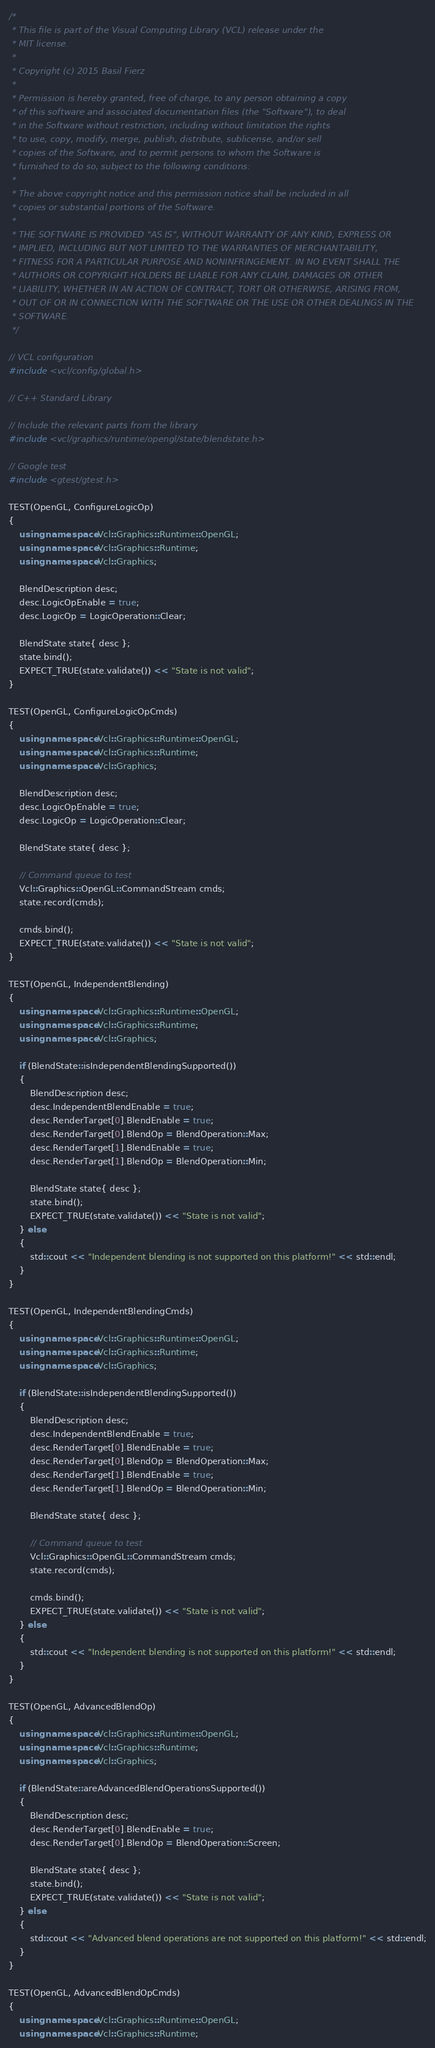Convert code to text. <code><loc_0><loc_0><loc_500><loc_500><_C++_>/*
 * This file is part of the Visual Computing Library (VCL) release under the
 * MIT license.
 *
 * Copyright (c) 2015 Basil Fierz
 *
 * Permission is hereby granted, free of charge, to any person obtaining a copy
 * of this software and associated documentation files (the "Software"), to deal
 * in the Software without restriction, including without limitation the rights
 * to use, copy, modify, merge, publish, distribute, sublicense, and/or sell
 * copies of the Software, and to permit persons to whom the Software is
 * furnished to do so, subject to the following conditions:
 *
 * The above copyright notice and this permission notice shall be included in all
 * copies or substantial portions of the Software.
 *
 * THE SOFTWARE IS PROVIDED "AS IS", WITHOUT WARRANTY OF ANY KIND, EXPRESS OR
 * IMPLIED, INCLUDING BUT NOT LIMITED TO THE WARRANTIES OF MERCHANTABILITY,
 * FITNESS FOR A PARTICULAR PURPOSE AND NONINFRINGEMENT. IN NO EVENT SHALL THE
 * AUTHORS OR COPYRIGHT HOLDERS BE LIABLE FOR ANY CLAIM, DAMAGES OR OTHER
 * LIABILITY, WHETHER IN AN ACTION OF CONTRACT, TORT OR OTHERWISE, ARISING FROM,
 * OUT OF OR IN CONNECTION WITH THE SOFTWARE OR THE USE OR OTHER DEALINGS IN THE
 * SOFTWARE.
 */

// VCL configuration
#include <vcl/config/global.h>

// C++ Standard Library

// Include the relevant parts from the library
#include <vcl/graphics/runtime/opengl/state/blendstate.h>

// Google test
#include <gtest/gtest.h>

TEST(OpenGL, ConfigureLogicOp)
{
	using namespace Vcl::Graphics::Runtime::OpenGL;
	using namespace Vcl::Graphics::Runtime;
	using namespace Vcl::Graphics;

	BlendDescription desc;
	desc.LogicOpEnable = true;
	desc.LogicOp = LogicOperation::Clear;

	BlendState state{ desc };
	state.bind();
	EXPECT_TRUE(state.validate()) << "State is not valid";
}

TEST(OpenGL, ConfigureLogicOpCmds)
{
	using namespace Vcl::Graphics::Runtime::OpenGL;
	using namespace Vcl::Graphics::Runtime;
	using namespace Vcl::Graphics;

	BlendDescription desc;
	desc.LogicOpEnable = true;
	desc.LogicOp = LogicOperation::Clear;

	BlendState state{ desc };

	// Command queue to test
	Vcl::Graphics::OpenGL::CommandStream cmds;
	state.record(cmds);

	cmds.bind();
	EXPECT_TRUE(state.validate()) << "State is not valid";
}

TEST(OpenGL, IndependentBlending)
{
	using namespace Vcl::Graphics::Runtime::OpenGL;
	using namespace Vcl::Graphics::Runtime;
	using namespace Vcl::Graphics;

	if (BlendState::isIndependentBlendingSupported())
	{
		BlendDescription desc;
		desc.IndependentBlendEnable = true;
		desc.RenderTarget[0].BlendEnable = true;
		desc.RenderTarget[0].BlendOp = BlendOperation::Max;
		desc.RenderTarget[1].BlendEnable = true;
		desc.RenderTarget[1].BlendOp = BlendOperation::Min;

		BlendState state{ desc };
		state.bind();
		EXPECT_TRUE(state.validate()) << "State is not valid";
	} else
	{
		std::cout << "Independent blending is not supported on this platform!" << std::endl;
	}
}

TEST(OpenGL, IndependentBlendingCmds)
{
	using namespace Vcl::Graphics::Runtime::OpenGL;
	using namespace Vcl::Graphics::Runtime;
	using namespace Vcl::Graphics;

	if (BlendState::isIndependentBlendingSupported())
	{
		BlendDescription desc;
		desc.IndependentBlendEnable = true;
		desc.RenderTarget[0].BlendEnable = true;
		desc.RenderTarget[0].BlendOp = BlendOperation::Max;
		desc.RenderTarget[1].BlendEnable = true;
		desc.RenderTarget[1].BlendOp = BlendOperation::Min;

		BlendState state{ desc };

		// Command queue to test
		Vcl::Graphics::OpenGL::CommandStream cmds;
		state.record(cmds);

		cmds.bind();
		EXPECT_TRUE(state.validate()) << "State is not valid";
	} else
	{
		std::cout << "Independent blending is not supported on this platform!" << std::endl;
	}
}

TEST(OpenGL, AdvancedBlendOp)
{
	using namespace Vcl::Graphics::Runtime::OpenGL;
	using namespace Vcl::Graphics::Runtime;
	using namespace Vcl::Graphics;

	if (BlendState::areAdvancedBlendOperationsSupported())
	{
		BlendDescription desc;
		desc.RenderTarget[0].BlendEnable = true;
		desc.RenderTarget[0].BlendOp = BlendOperation::Screen;

		BlendState state{ desc };
		state.bind();
		EXPECT_TRUE(state.validate()) << "State is not valid";
	} else
	{
		std::cout << "Advanced blend operations are not supported on this platform!" << std::endl;
	}
}

TEST(OpenGL, AdvancedBlendOpCmds)
{
	using namespace Vcl::Graphics::Runtime::OpenGL;
	using namespace Vcl::Graphics::Runtime;</code> 